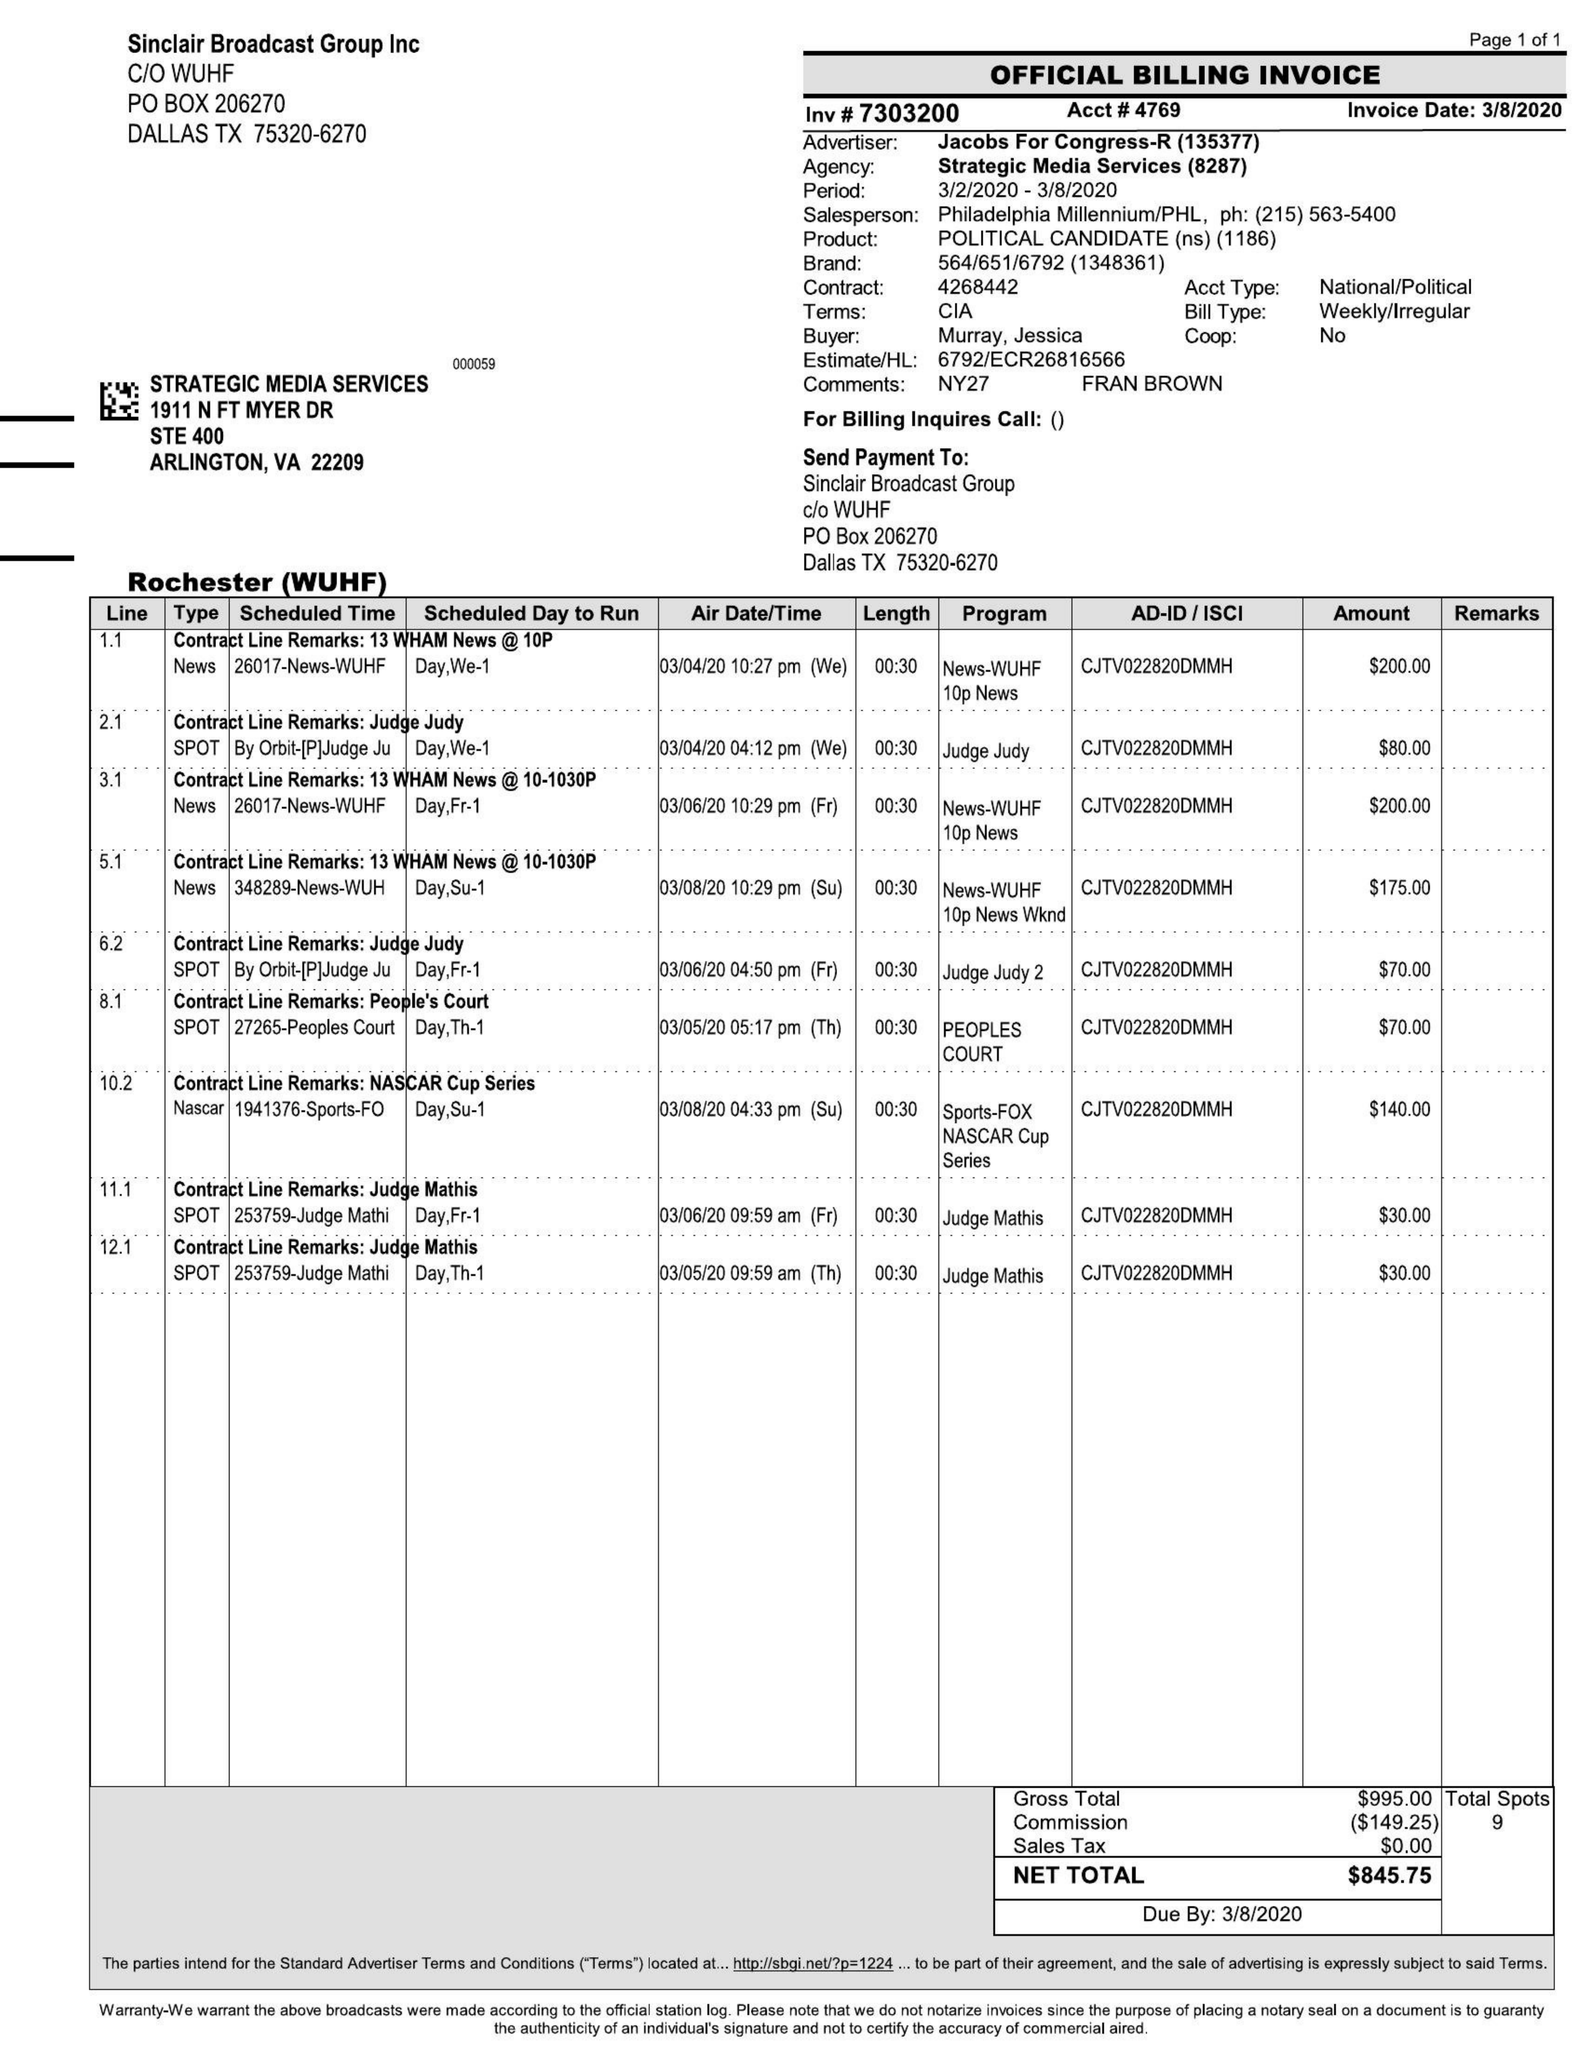What is the value for the flight_from?
Answer the question using a single word or phrase. 03/04/20 